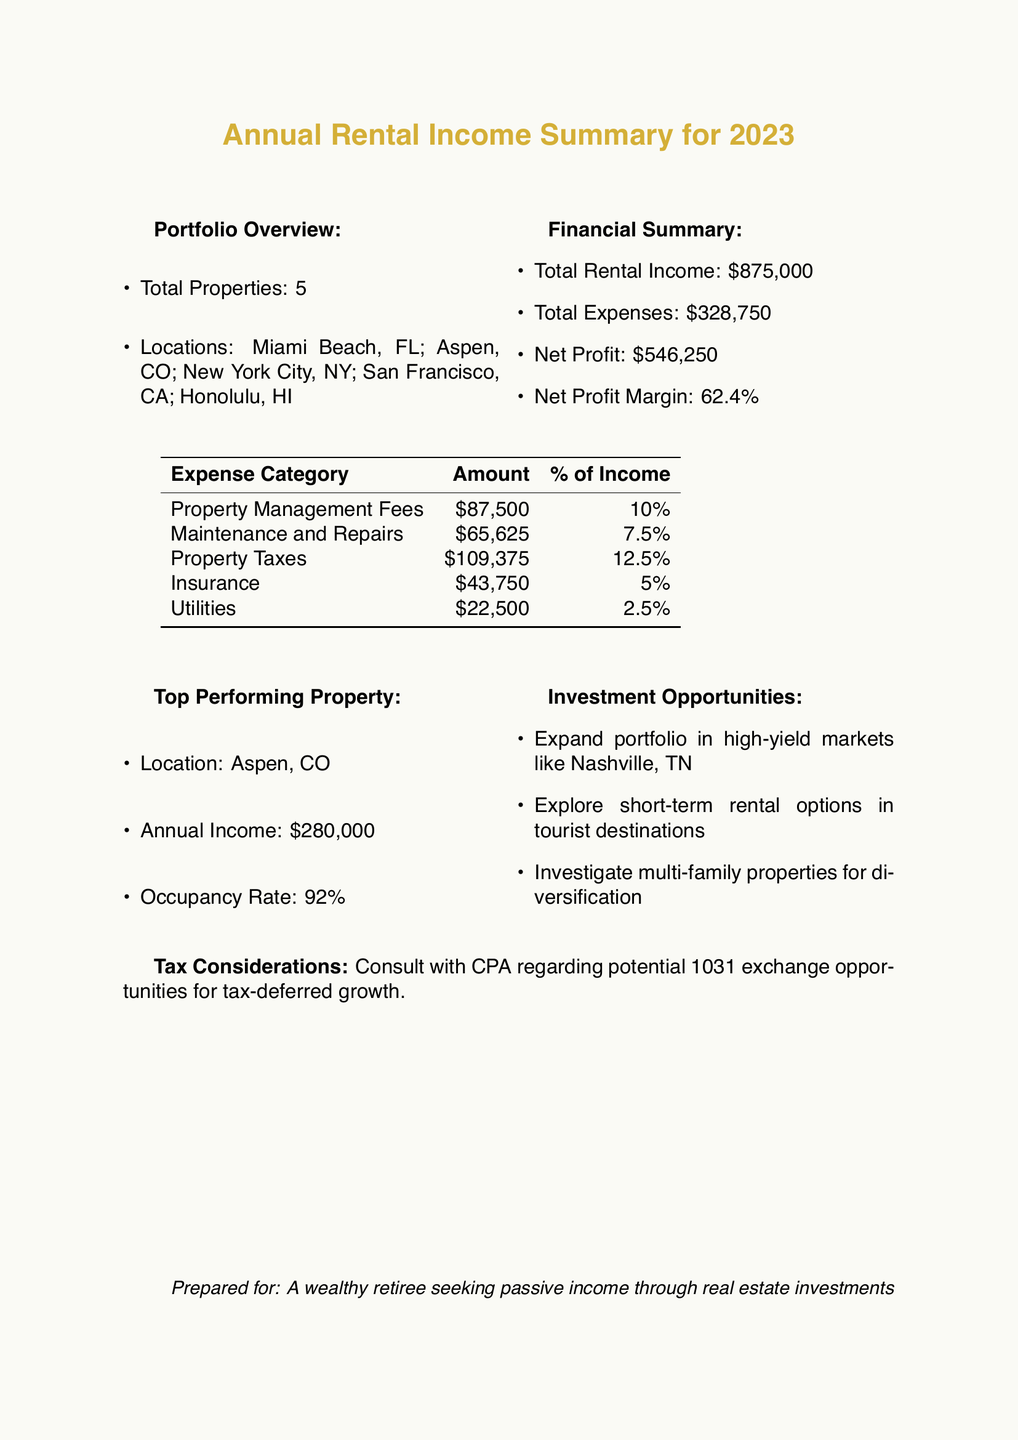what is the total rental income? The total rental income is stated in the financial summary of the document, which is $875,000.
Answer: $875,000 what is the net profit margin? The net profit margin is calculated as net profit divided by total rental income, which is provided in the financial summary as 62.4%.
Answer: 62.4% how many properties are in the portfolio? The total number of properties is detailed in the portfolio overview section of the document, which mentions 5 properties.
Answer: 5 which property generated the highest income? The top performing property is listed in the document, specifically identifying Aspen, CO as the location with the highest annual income.
Answer: Aspen, CO what is the amount spent on property management fees? The expense breakdown specifies the amount allocated to property management fees as $87,500.
Answer: $87,500 what is the occupancy rate of the top-performing property? The occupancy rate for the top performing property is indicated in the document as 92%.
Answer: 92% which market is suggested for portfolio expansion? The investment opportunities section suggests expanding into high-yield markets, specifically naming Nashville, TN.
Answer: Nashville, TN what type of tax strategy is recommended? The document suggests consulting with a CPA regarding potential tax-deferred growth opportunities under a 1031 exchange.
Answer: 1031 exchange 